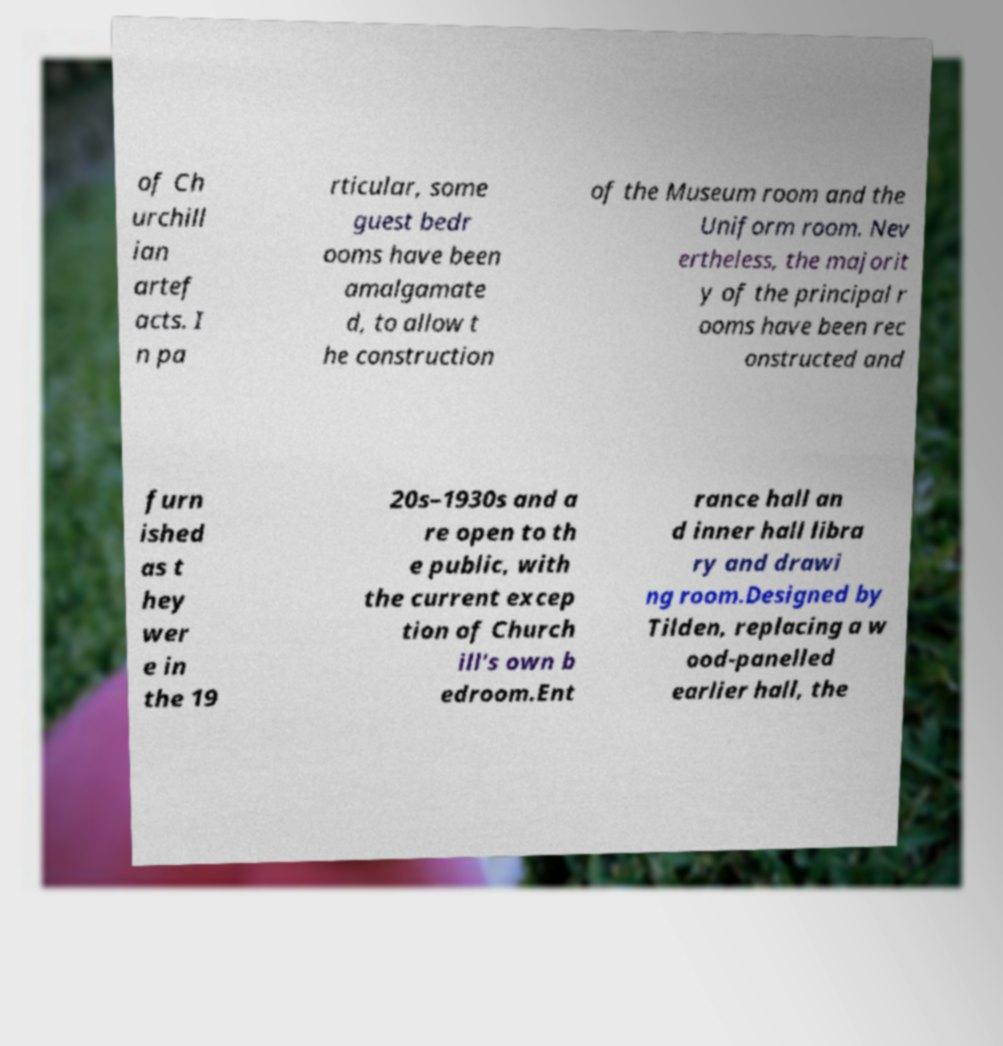I need the written content from this picture converted into text. Can you do that? of Ch urchill ian artef acts. I n pa rticular, some guest bedr ooms have been amalgamate d, to allow t he construction of the Museum room and the Uniform room. Nev ertheless, the majorit y of the principal r ooms have been rec onstructed and furn ished as t hey wer e in the 19 20s–1930s and a re open to th e public, with the current excep tion of Church ill's own b edroom.Ent rance hall an d inner hall libra ry and drawi ng room.Designed by Tilden, replacing a w ood-panelled earlier hall, the 